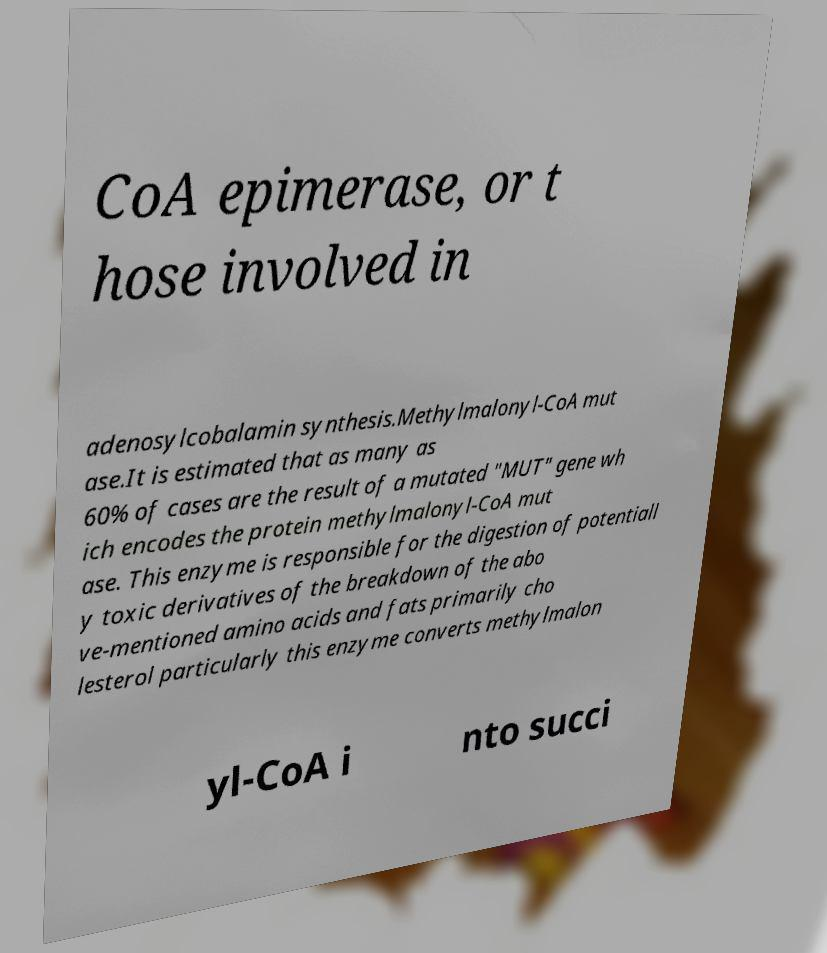I need the written content from this picture converted into text. Can you do that? CoA epimerase, or t hose involved in adenosylcobalamin synthesis.Methylmalonyl-CoA mut ase.It is estimated that as many as 60% of cases are the result of a mutated "MUT" gene wh ich encodes the protein methylmalonyl-CoA mut ase. This enzyme is responsible for the digestion of potentiall y toxic derivatives of the breakdown of the abo ve-mentioned amino acids and fats primarily cho lesterol particularly this enzyme converts methylmalon yl-CoA i nto succi 